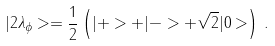Convert formula to latex. <formula><loc_0><loc_0><loc_500><loc_500>| 2 \lambda _ { \phi } > = \frac { 1 } { 2 } \left ( | + > + | - > + \sqrt { 2 } | 0 > \right ) \, .</formula> 